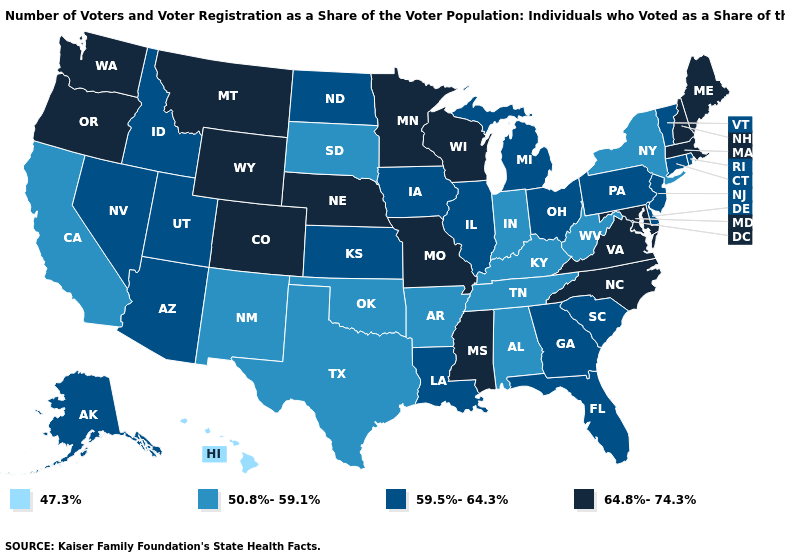What is the highest value in the MidWest ?
Keep it brief. 64.8%-74.3%. Among the states that border Oregon , does Washington have the highest value?
Keep it brief. Yes. Name the states that have a value in the range 47.3%?
Short answer required. Hawaii. Does Mississippi have the lowest value in the South?
Keep it brief. No. Among the states that border Montana , does North Dakota have the lowest value?
Answer briefly. No. Name the states that have a value in the range 59.5%-64.3%?
Write a very short answer. Alaska, Arizona, Connecticut, Delaware, Florida, Georgia, Idaho, Illinois, Iowa, Kansas, Louisiana, Michigan, Nevada, New Jersey, North Dakota, Ohio, Pennsylvania, Rhode Island, South Carolina, Utah, Vermont. Does New Jersey have the same value as Kansas?
Answer briefly. Yes. Name the states that have a value in the range 50.8%-59.1%?
Keep it brief. Alabama, Arkansas, California, Indiana, Kentucky, New Mexico, New York, Oklahoma, South Dakota, Tennessee, Texas, West Virginia. What is the value of Alaska?
Quick response, please. 59.5%-64.3%. Is the legend a continuous bar?
Write a very short answer. No. Name the states that have a value in the range 47.3%?
Short answer required. Hawaii. Does Wisconsin have the lowest value in the MidWest?
Give a very brief answer. No. What is the value of Mississippi?
Answer briefly. 64.8%-74.3%. Among the states that border Missouri , which have the highest value?
Quick response, please. Nebraska. What is the highest value in states that border Idaho?
Be succinct. 64.8%-74.3%. 